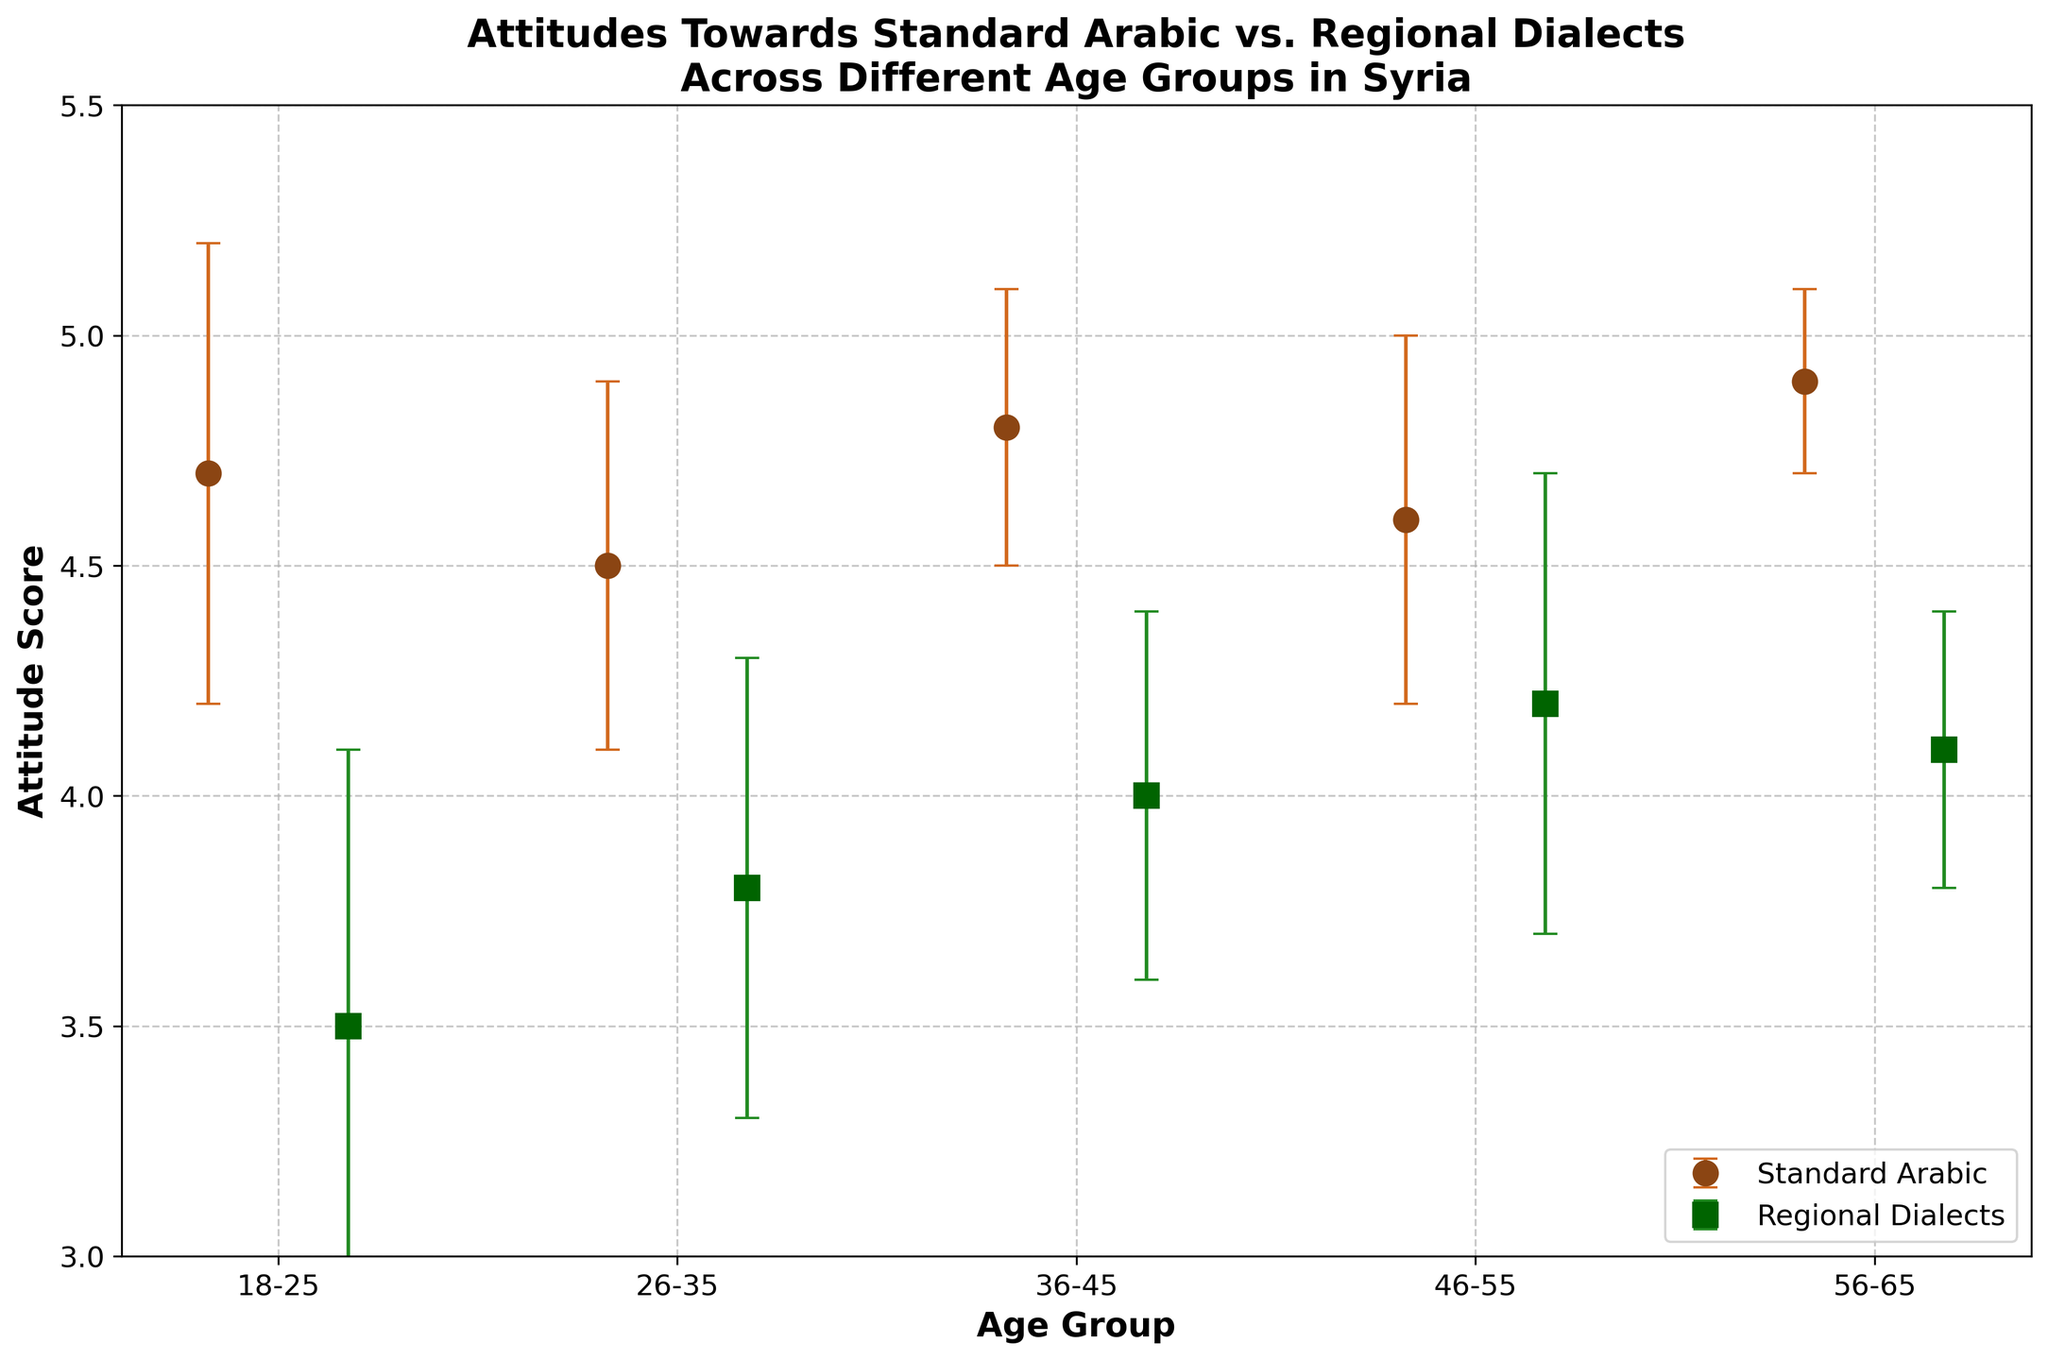Which age group has the highest mean attitude score towards Standard Arabic? To answer this, identify the age group with the highest mean value for Standard Arabic (y-value). The highest mean for Standard Arabic is 4.9, which occurs in the 56-65 age group
Answer: 56-65 Which age group shows the least favorable attitude towards Regional Dialects? Locate the lowest mean value for Regional Dialects on the y-axis. The lowest mean for Regional Dialects is 3.5, which is in the 18-25 age group
Answer: 18-25 What are the mean attitude scores for the 36-45 age group towards both Standard Arabic and Regional Dialects? Check the plotted points for the 36-45 age group along both Standard Arabic and Regional Dialects. The mean scores are 4.8 for Standard Arabic and 4.0 for Regional Dialects
Answer: 4.8 for Standard Arabic and 4.0 for Regional Dialects Which type of attitude shows a larger variance (indicated by error bars) in the 18-25 age group? Compare the error bars' lengths for both Standard Arabic and Regional Dialects in the 18-25 age group. The error for Standard Arabic is 0.5 and for Regional Dialects is 0.6. Regional Dialects has a larger variance
Answer: Regional Dialects How does the attitude towards Regional Dialects change from the 18-25 age group to the 56-65 age group? Observe the mean values for Regional Dialects in the 18-25 and 56-65 age groups. The mean increases from 3.5 to 4.1
Answer: It increases Are the attitudes towards Standard Arabic relatively stable across age groups? Compare the mean scores and error bars for Standard Arabic across different age groups. The scores are generally between 4.5 to 4.9 with small variances, indicating stability
Answer: Yes What age group shows the smallest error margin for attitudes towards Standard Arabic? Look at the error values for Standard Arabic across all age groups and find the smallest. The smallest error is 0.2 in the 56-65 age group
Answer: 56-65 Compare the average attitude scores towards Regional Dialects between the youngest (18-25) and the oldest (56-65) age groups. Find the mean scores for these age groups for Regional Dialects and compare them. The scores are 3.5 for the youngest and 4.1 for the oldest
Answer: 3.5 for the youngest, 4.1 for the oldest Which age group has the largest difference in attitudes between Standard Arabic and Regional Dialects? Calculate the difference between the means of Standard Arabic and Regional Dialects for each age group. The largest difference is 1.2 in the 18-25 age group
Answer: 18-25 Are there any age groups where attitudes towards Standard Arabic and Regional Dialects are almost equal? Compare the mean values across age groups. The closest mean values are in the 46-55 age group with scores of 4.6 and 4.2
Answer: No 